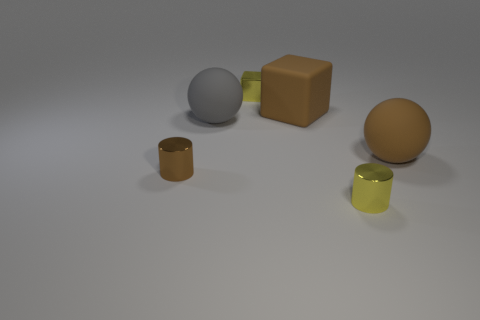Can you describe the texture and lighting conditions in the image? The objects appear to have a matte finish with no reflections, indicating a non-glossy texture. The lighting is soft and diffused, coming from above and casting gentle shadows beneath the objects, giving the scene a calm and evenly lit appearance. 